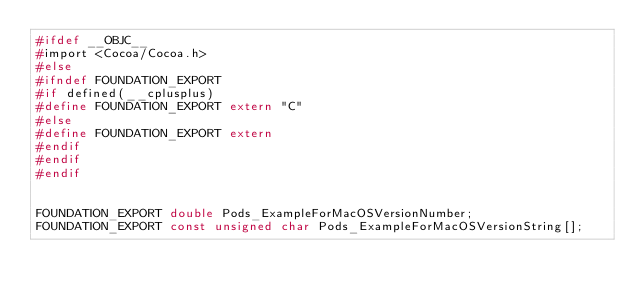Convert code to text. <code><loc_0><loc_0><loc_500><loc_500><_C_>#ifdef __OBJC__
#import <Cocoa/Cocoa.h>
#else
#ifndef FOUNDATION_EXPORT
#if defined(__cplusplus)
#define FOUNDATION_EXPORT extern "C"
#else
#define FOUNDATION_EXPORT extern
#endif
#endif
#endif


FOUNDATION_EXPORT double Pods_ExampleForMacOSVersionNumber;
FOUNDATION_EXPORT const unsigned char Pods_ExampleForMacOSVersionString[];

</code> 